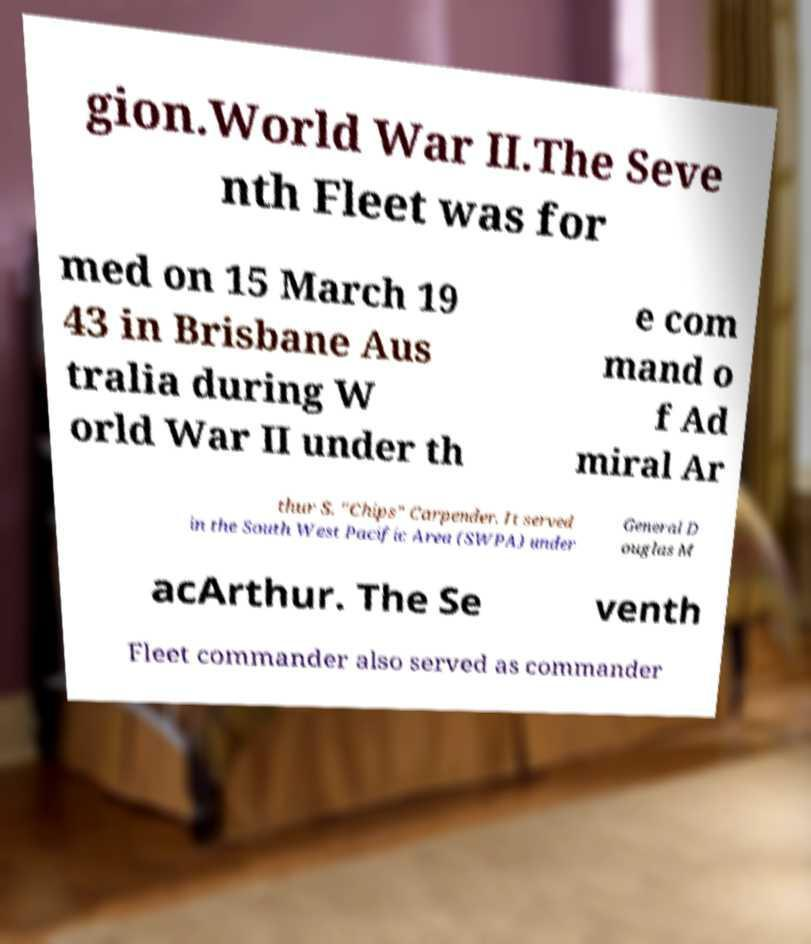Please identify and transcribe the text found in this image. gion.World War II.The Seve nth Fleet was for med on 15 March 19 43 in Brisbane Aus tralia during W orld War II under th e com mand o f Ad miral Ar thur S. "Chips" Carpender. It served in the South West Pacific Area (SWPA) under General D ouglas M acArthur. The Se venth Fleet commander also served as commander 